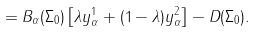Convert formula to latex. <formula><loc_0><loc_0><loc_500><loc_500>= B _ { \alpha } ( { \Sigma _ { 0 } } ) \left [ \lambda y ^ { 1 } _ { \alpha } + ( 1 - \lambda ) y ^ { 2 } _ { \alpha } \right ] - D ( { \Sigma _ { 0 } } ) .</formula> 